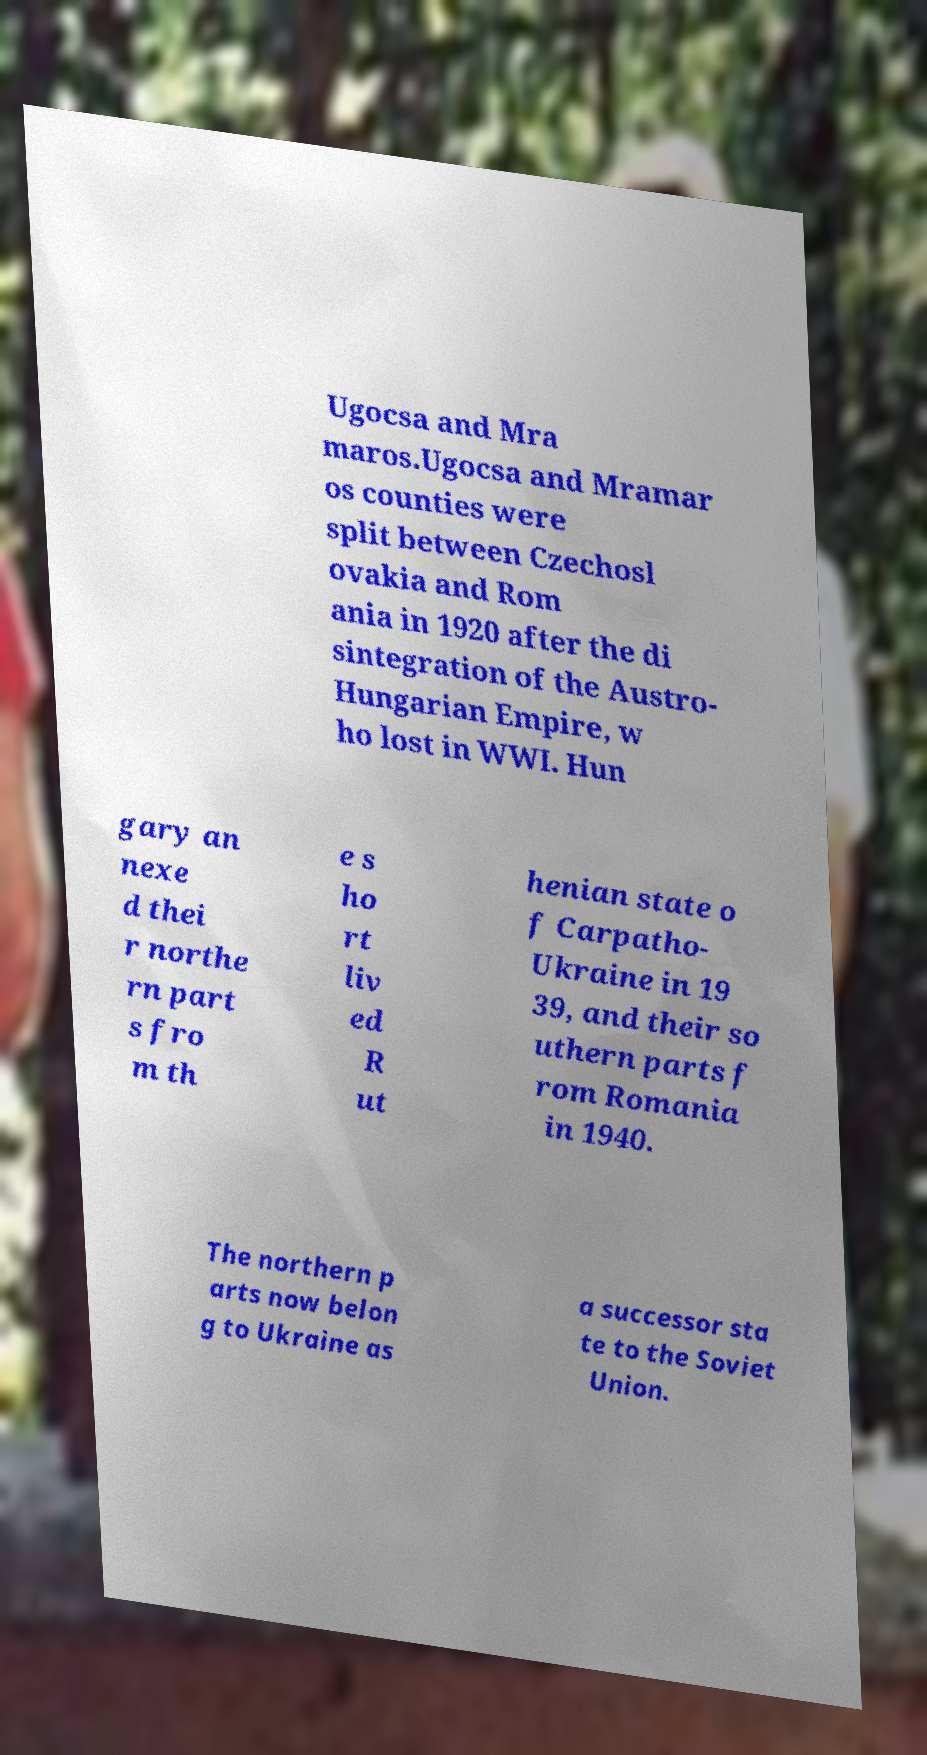Could you extract and type out the text from this image? Ugocsa and Mra maros.Ugocsa and Mramar os counties were split between Czechosl ovakia and Rom ania in 1920 after the di sintegration of the Austro- Hungarian Empire, w ho lost in WWI. Hun gary an nexe d thei r northe rn part s fro m th e s ho rt liv ed R ut henian state o f Carpatho- Ukraine in 19 39, and their so uthern parts f rom Romania in 1940. The northern p arts now belon g to Ukraine as a successor sta te to the Soviet Union. 